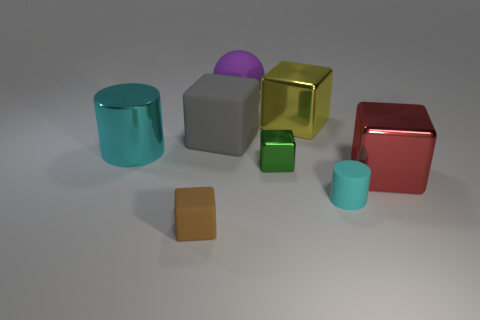Subtract all gray matte cubes. How many cubes are left? 4 Subtract all green blocks. How many blocks are left? 4 Subtract all purple cubes. Subtract all gray cylinders. How many cubes are left? 5 Add 1 big purple metallic cylinders. How many objects exist? 9 Subtract all spheres. How many objects are left? 7 Add 7 matte balls. How many matte balls are left? 8 Add 1 tiny brown rubber cubes. How many tiny brown rubber cubes exist? 2 Subtract 0 purple cylinders. How many objects are left? 8 Subtract all gray matte blocks. Subtract all matte objects. How many objects are left? 3 